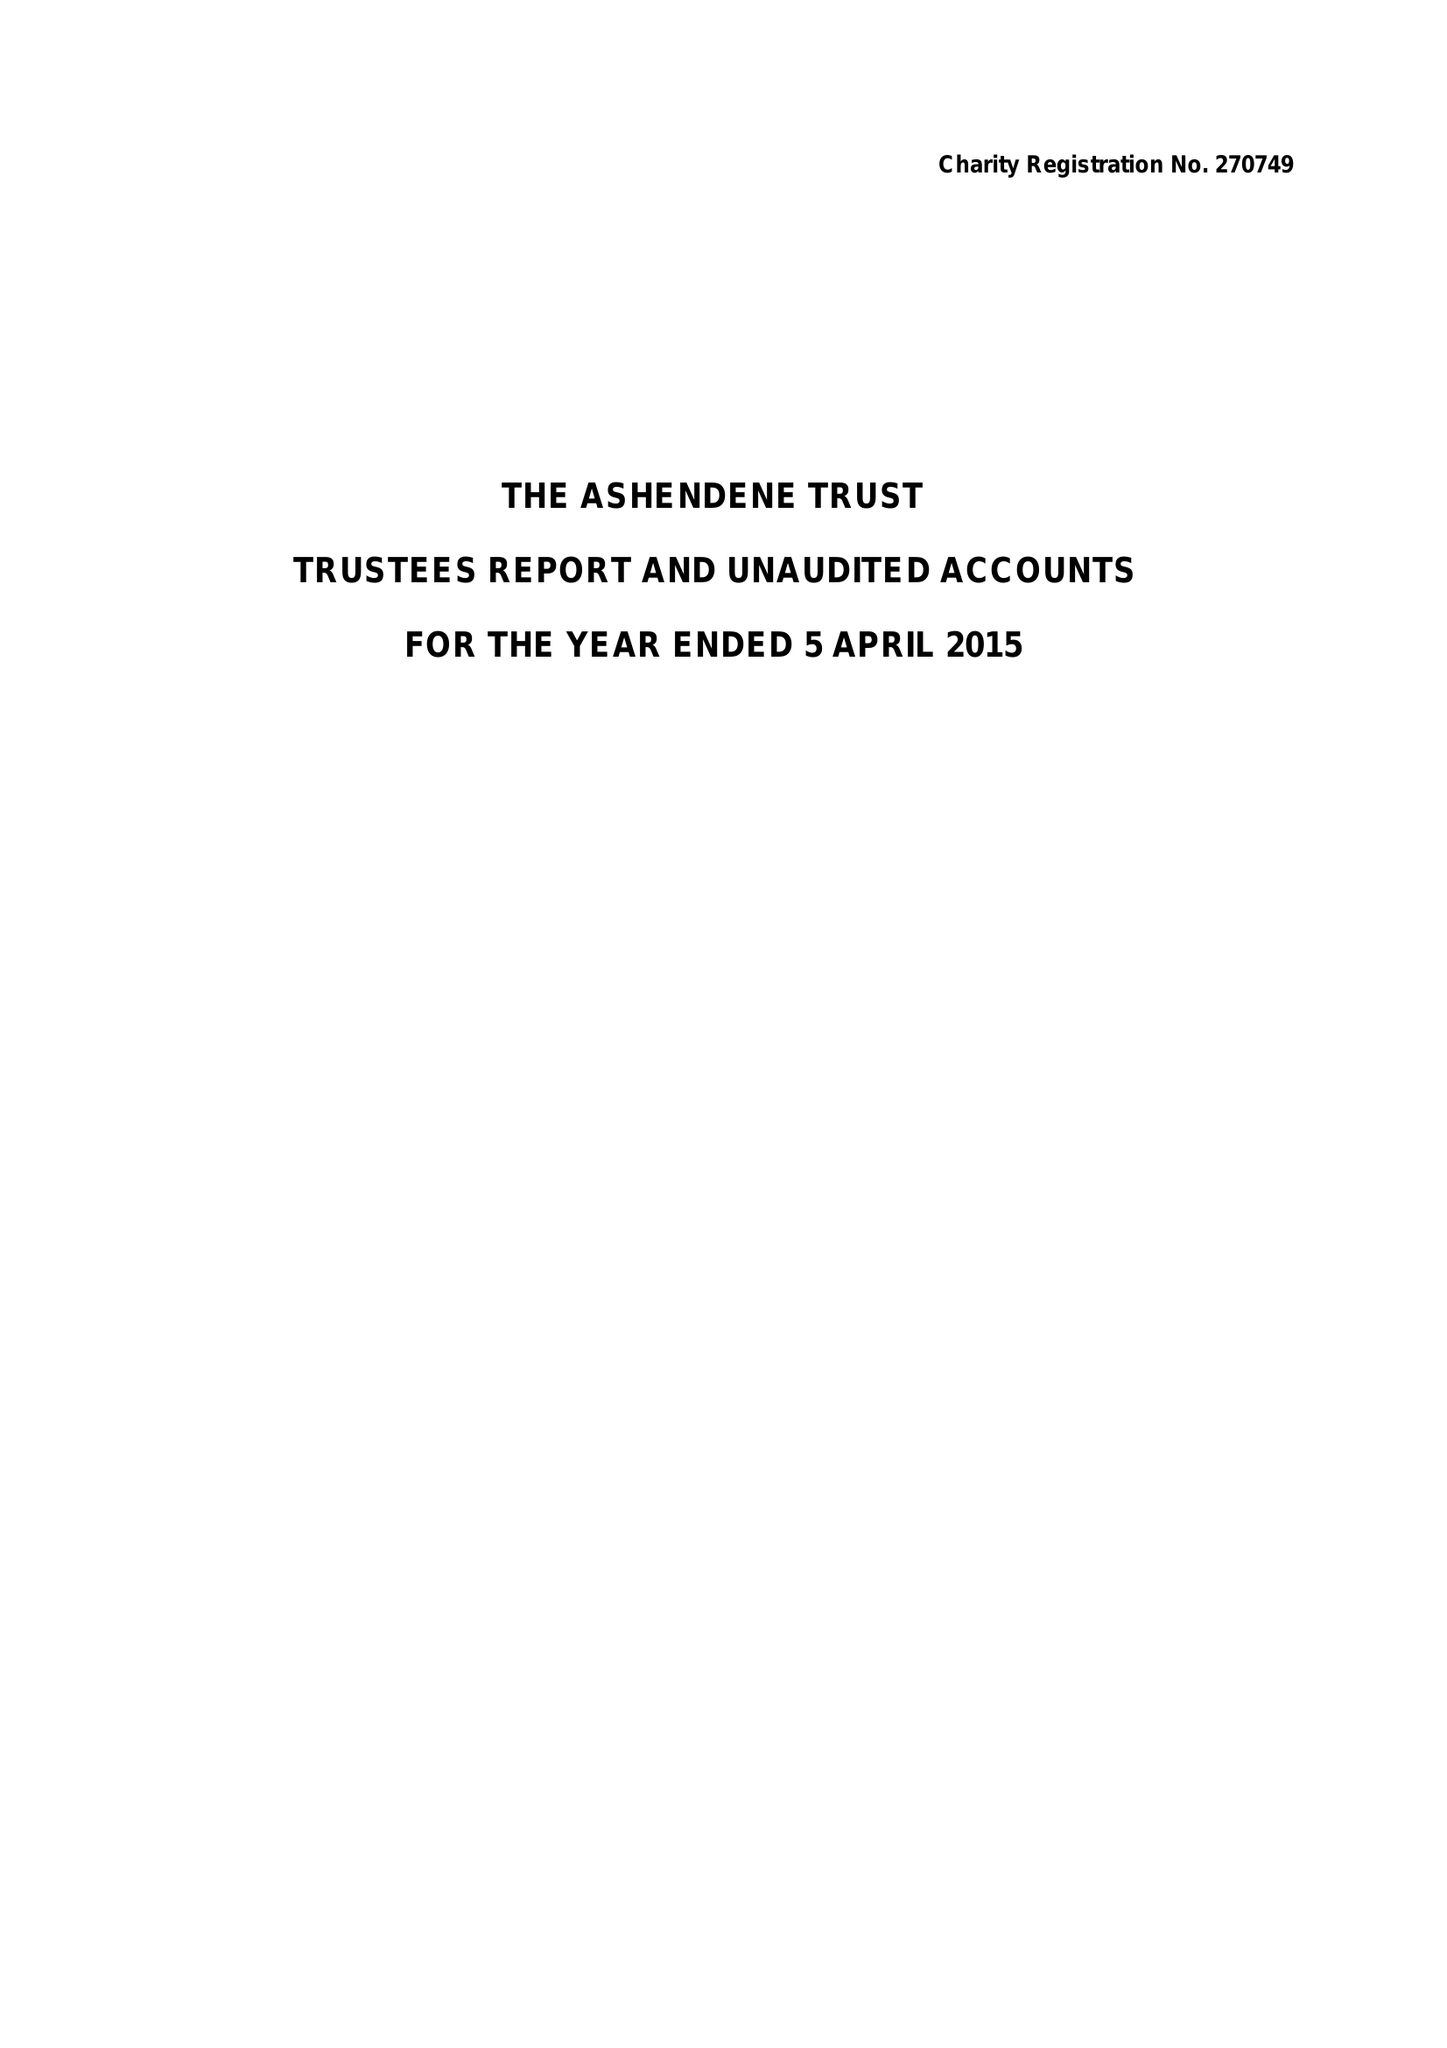What is the value for the address__post_town?
Answer the question using a single word or phrase. LONDON 